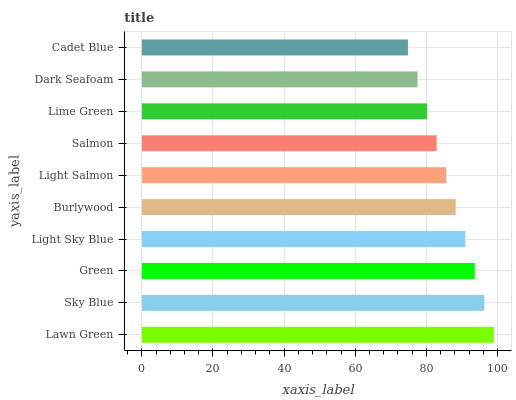Is Cadet Blue the minimum?
Answer yes or no. Yes. Is Lawn Green the maximum?
Answer yes or no. Yes. Is Sky Blue the minimum?
Answer yes or no. No. Is Sky Blue the maximum?
Answer yes or no. No. Is Lawn Green greater than Sky Blue?
Answer yes or no. Yes. Is Sky Blue less than Lawn Green?
Answer yes or no. Yes. Is Sky Blue greater than Lawn Green?
Answer yes or no. No. Is Lawn Green less than Sky Blue?
Answer yes or no. No. Is Burlywood the high median?
Answer yes or no. Yes. Is Light Salmon the low median?
Answer yes or no. Yes. Is Light Sky Blue the high median?
Answer yes or no. No. Is Lime Green the low median?
Answer yes or no. No. 